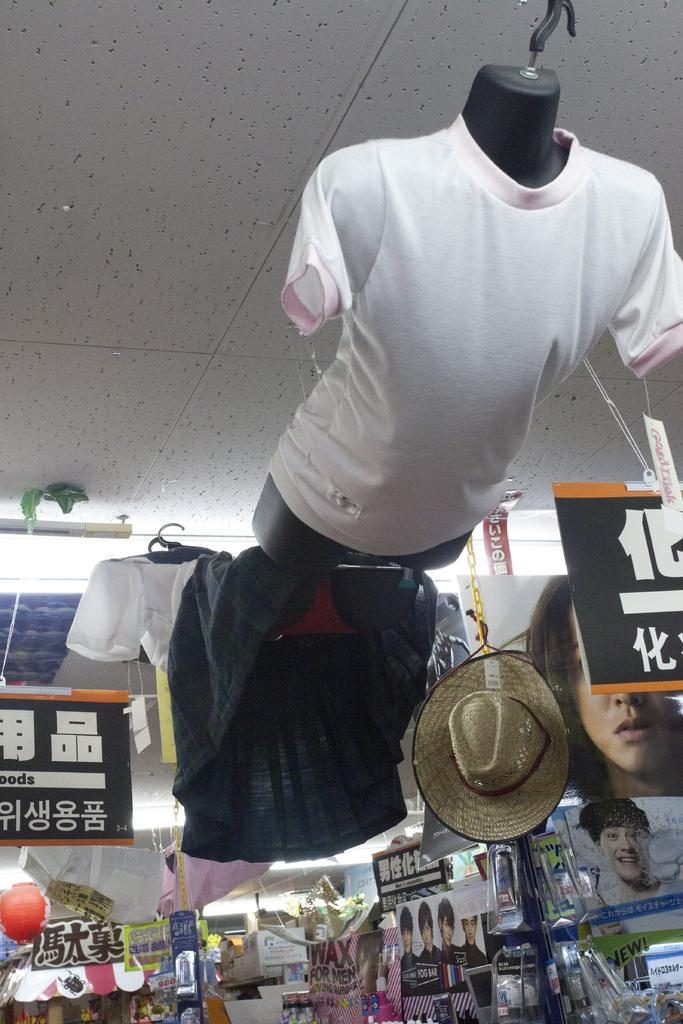What type of clothing item is on the mannequin in the image? There is a t-shirt on a mannequin in the image. What else can be seen in the image besides the t-shirt? There are clothes, a hat, boards, and other objects in the store in the image. How is the hat positioned in the image? The hat is hanging in the image. What type of objects might be found in a store setting? Clothes, hats, and other merchandise can be found in a store setting. What does the t-shirt taste like in the image? The t-shirt does not have a taste, as it is a clothing item and not a food item. 